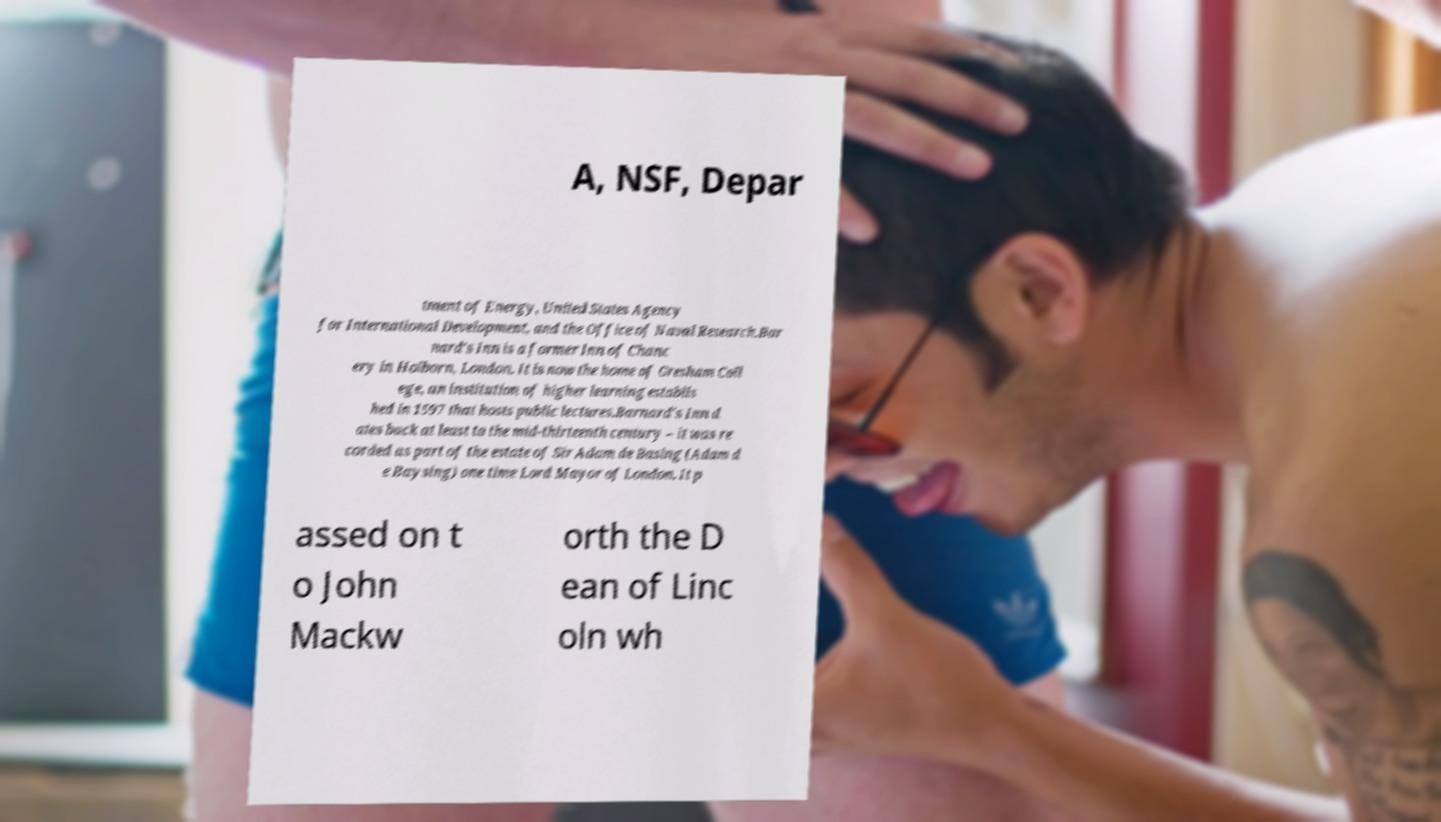Could you extract and type out the text from this image? A, NSF, Depar tment of Energy, United States Agency for International Development, and the Office of Naval Research.Bar nard's Inn is a former Inn of Chanc ery in Holborn, London. It is now the home of Gresham Coll ege, an institution of higher learning establis hed in 1597 that hosts public lectures.Barnard's Inn d ates back at least to the mid-thirteenth century – it was re corded as part of the estate of Sir Adam de Basing (Adam d e Baysing) one time Lord Mayor of London. It p assed on t o John Mackw orth the D ean of Linc oln wh 